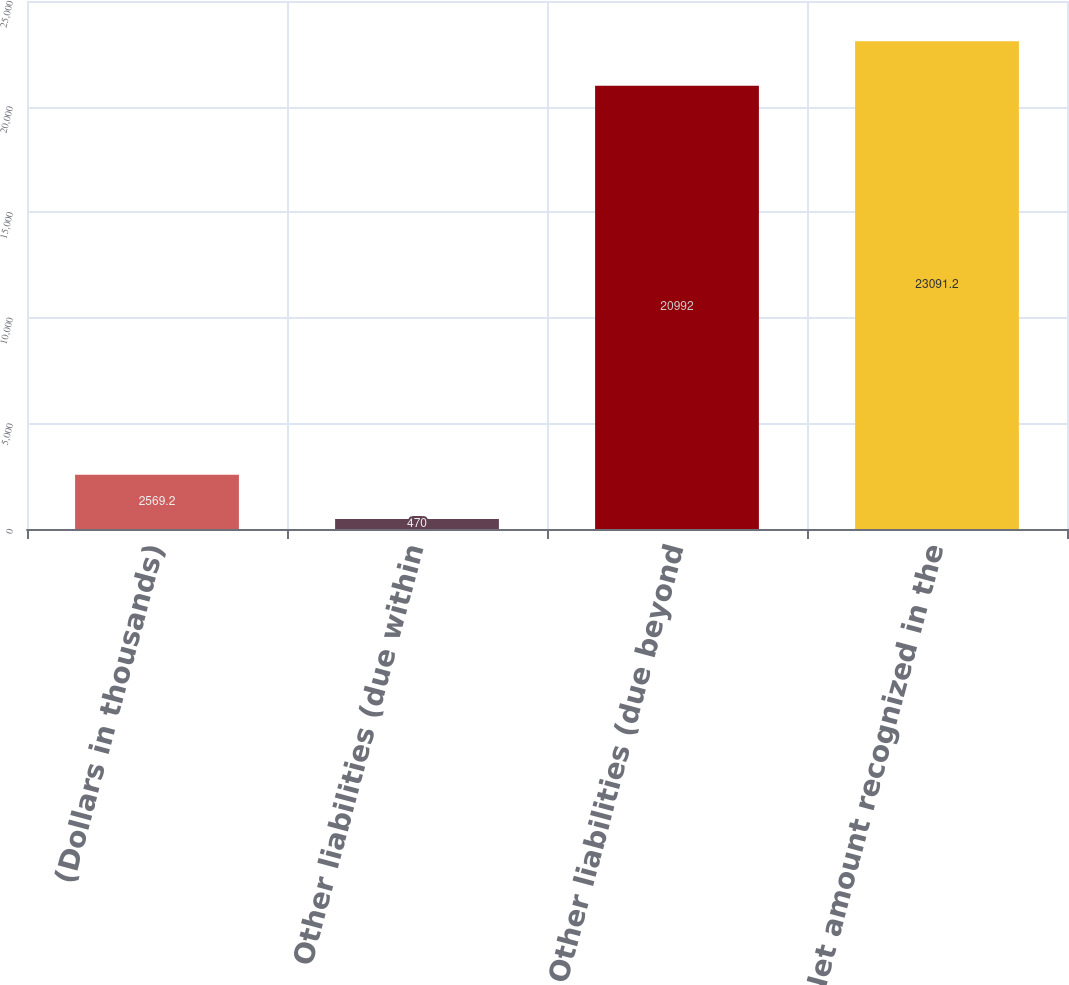Convert chart to OTSL. <chart><loc_0><loc_0><loc_500><loc_500><bar_chart><fcel>(Dollars in thousands)<fcel>Other liabilities (due within<fcel>Other liabilities (due beyond<fcel>Net amount recognized in the<nl><fcel>2569.2<fcel>470<fcel>20992<fcel>23091.2<nl></chart> 